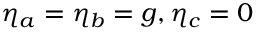Convert formula to latex. <formula><loc_0><loc_0><loc_500><loc_500>\eta _ { a } = \eta _ { b } = g , \eta _ { c } = 0</formula> 